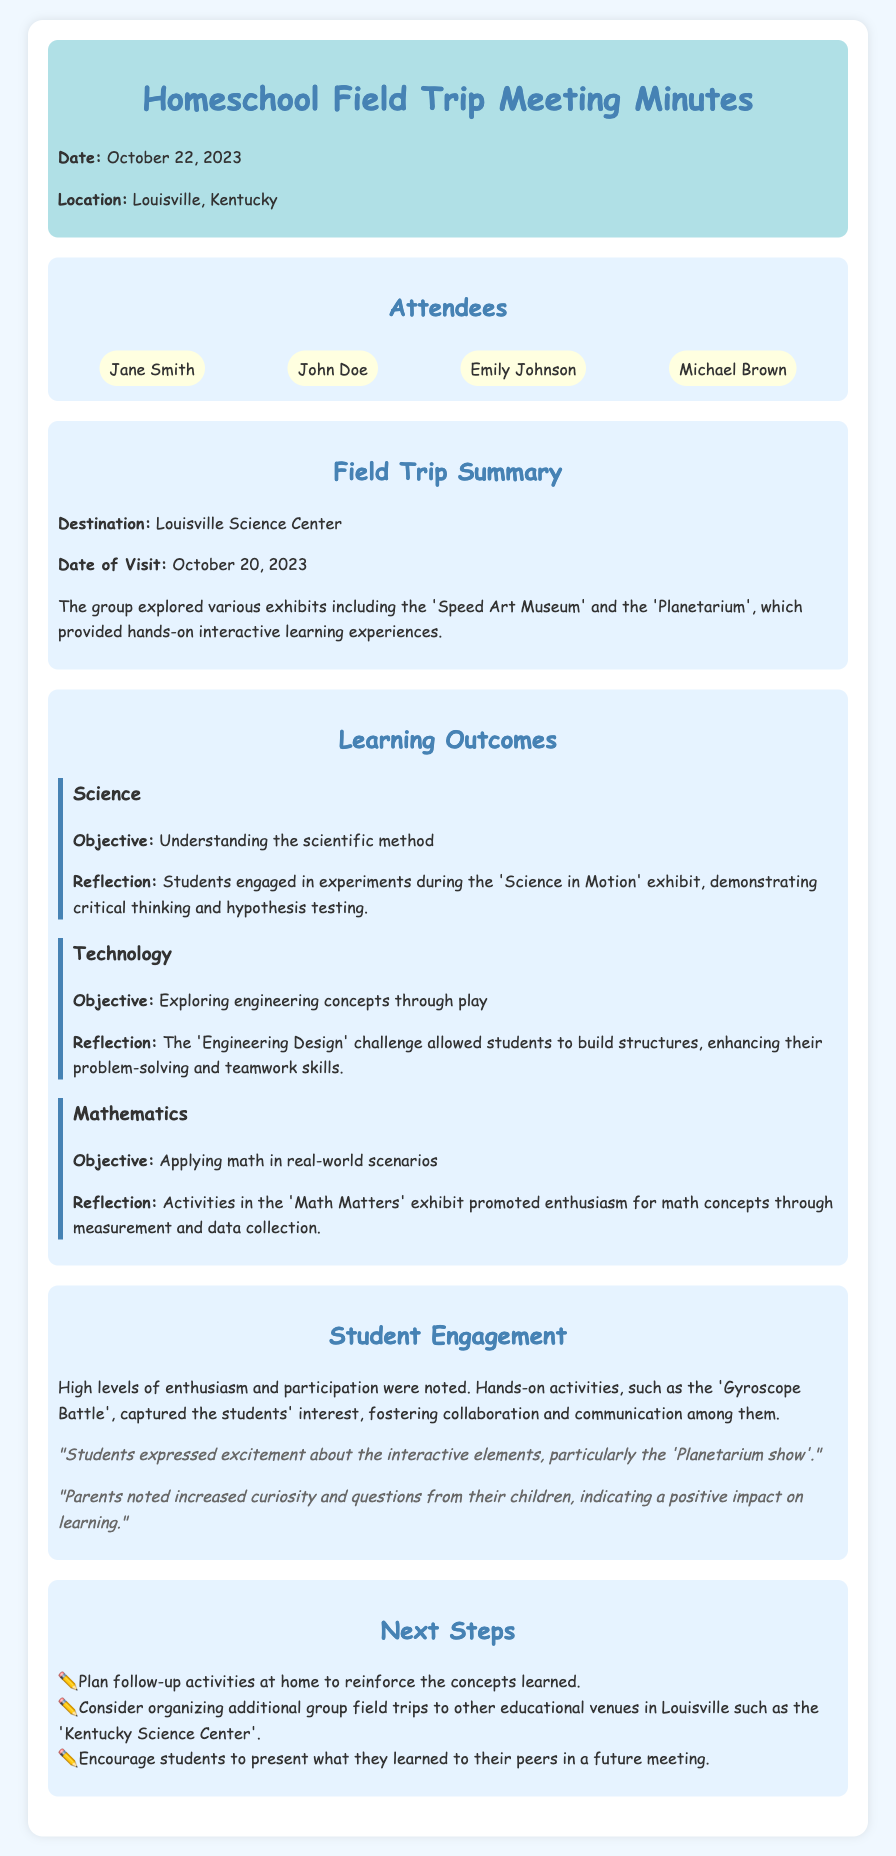What was the date of the field trip? The date of the field trip is stated in the document, which is October 20, 2023.
Answer: October 20, 2023 Who was the first attendee listed? The attendees' names are listed in the document, with Jane Smith being the first.
Answer: Jane Smith What was the main destination of the field trip? The document specifies that the destination of the field trip was the Louisville Science Center.
Answer: Louisville Science Center What type of exhibit focused on mathematics? The document mentions an exhibit related to mathematics by specifying the 'Math Matters' exhibit.
Answer: Math Matters How many learning outcomes were discussed? The document identifies three distinct learning outcomes in the summary section.
Answer: Three What activity showed high levels of student engagement? The document highlights the 'Gyroscope Battle' as an activity that captured student interest.
Answer: Gyroscope Battle What did students express excitement about? The feedback section notes that students were particularly excited about the 'Planetarium show'.
Answer: Planetarium show What is one next step mentioned for reinforcing learned concepts? The document suggests planning follow-up activities at home to reinforce concepts learned.
Answer: Plan follow-up activities at home What type of skills did the Engineering Design challenge enhance? The document indicates that the challenge enhanced problem-solving and teamwork skills.
Answer: Problem-solving and teamwork skills 